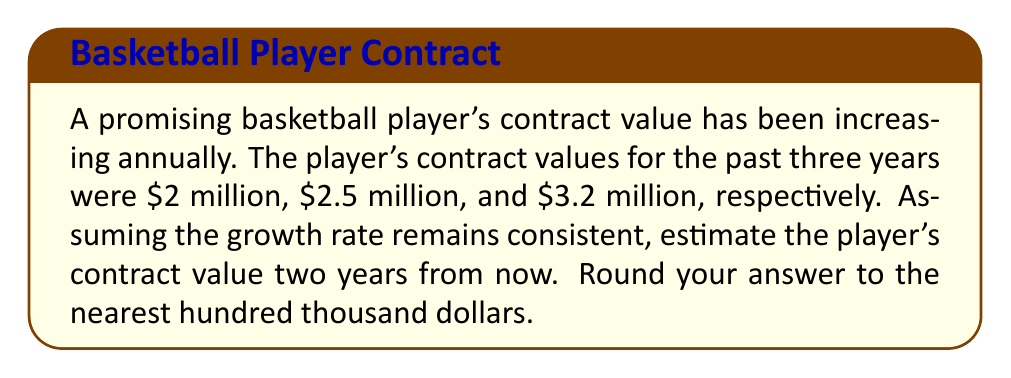Help me with this question. To solve this problem, we need to:
1. Calculate the average growth rate
2. Apply this growth rate to project future contract values

Step 1: Calculate the average growth rate

Let's define the growth rate between two consecutive years as:
$$ r = \frac{\text{New Value} - \text{Previous Value}}{\text{Previous Value}} $$

Growth rate from year 1 to year 2:
$$ r_1 = \frac{2.5 - 2}{2} = 0.25 \text{ or } 25\% $$

Growth rate from year 2 to year 3:
$$ r_2 = \frac{3.2 - 2.5}{2.5} = 0.28 \text{ or } 28\% $$

Average growth rate:
$$ \bar{r} = \frac{r_1 + r_2}{2} = \frac{0.25 + 0.28}{2} = 0.265 \text{ or } 26.5\% $$

Step 2: Project future contract values

Year 4 (next year):
$$ V_4 = 3.2 \times (1 + 0.265) = 4.048 \text{ million} $$

Year 5 (two years from now):
$$ V_5 = 4.048 \times (1 + 0.265) = 5.12072 \text{ million} $$

Rounding to the nearest hundred thousand:
$$ V_5 \approx 5.1 \text{ million} $$
Answer: $5.1 million 